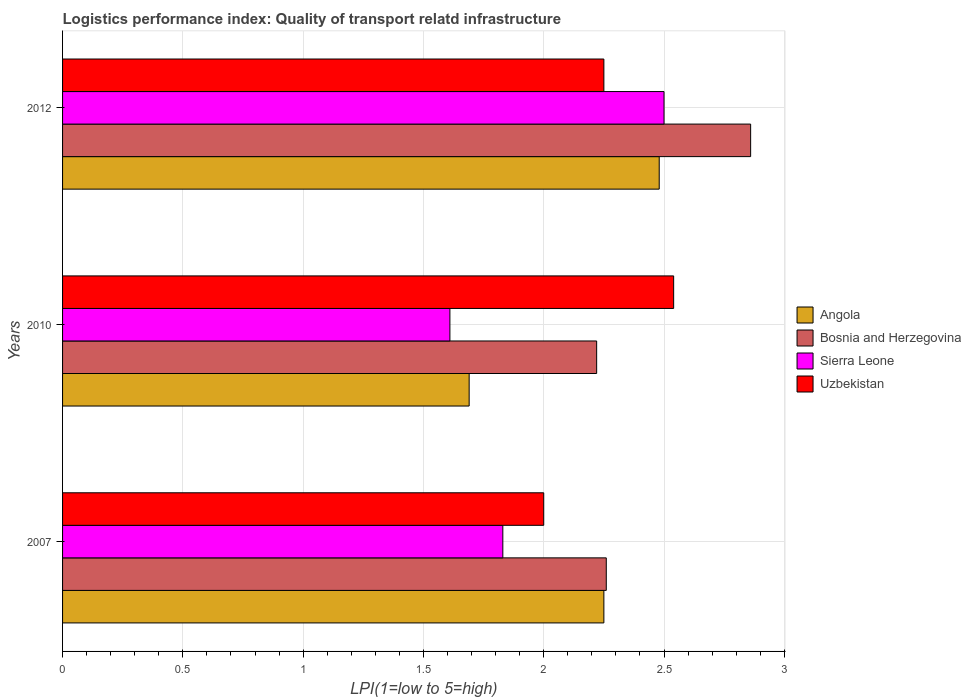How many different coloured bars are there?
Give a very brief answer. 4. How many groups of bars are there?
Provide a short and direct response. 3. Are the number of bars per tick equal to the number of legend labels?
Your response must be concise. Yes. Are the number of bars on each tick of the Y-axis equal?
Offer a terse response. Yes. How many bars are there on the 2nd tick from the top?
Your response must be concise. 4. What is the label of the 2nd group of bars from the top?
Ensure brevity in your answer.  2010. In how many cases, is the number of bars for a given year not equal to the number of legend labels?
Your answer should be compact. 0. What is the logistics performance index in Bosnia and Herzegovina in 2010?
Offer a very short reply. 2.22. Across all years, what is the maximum logistics performance index in Angola?
Keep it short and to the point. 2.48. Across all years, what is the minimum logistics performance index in Angola?
Offer a terse response. 1.69. In which year was the logistics performance index in Angola maximum?
Provide a short and direct response. 2012. What is the total logistics performance index in Bosnia and Herzegovina in the graph?
Provide a succinct answer. 7.34. What is the difference between the logistics performance index in Angola in 2007 and that in 2010?
Make the answer very short. 0.56. What is the difference between the logistics performance index in Uzbekistan in 2007 and the logistics performance index in Bosnia and Herzegovina in 2012?
Provide a succinct answer. -0.86. What is the average logistics performance index in Uzbekistan per year?
Ensure brevity in your answer.  2.26. In the year 2010, what is the difference between the logistics performance index in Sierra Leone and logistics performance index in Bosnia and Herzegovina?
Your response must be concise. -0.61. What is the ratio of the logistics performance index in Bosnia and Herzegovina in 2007 to that in 2010?
Give a very brief answer. 1.02. Is the difference between the logistics performance index in Sierra Leone in 2010 and 2012 greater than the difference between the logistics performance index in Bosnia and Herzegovina in 2010 and 2012?
Make the answer very short. No. What is the difference between the highest and the second highest logistics performance index in Sierra Leone?
Provide a short and direct response. 0.67. What is the difference between the highest and the lowest logistics performance index in Sierra Leone?
Keep it short and to the point. 0.89. Is it the case that in every year, the sum of the logistics performance index in Uzbekistan and logistics performance index in Sierra Leone is greater than the sum of logistics performance index in Bosnia and Herzegovina and logistics performance index in Angola?
Ensure brevity in your answer.  No. What does the 3rd bar from the top in 2007 represents?
Your response must be concise. Bosnia and Herzegovina. What does the 2nd bar from the bottom in 2012 represents?
Your answer should be compact. Bosnia and Herzegovina. How many bars are there?
Ensure brevity in your answer.  12. Are all the bars in the graph horizontal?
Make the answer very short. Yes. What is the difference between two consecutive major ticks on the X-axis?
Your answer should be compact. 0.5. Does the graph contain any zero values?
Your answer should be very brief. No. How many legend labels are there?
Your response must be concise. 4. What is the title of the graph?
Ensure brevity in your answer.  Logistics performance index: Quality of transport relatd infrastructure. Does "Europe(developing only)" appear as one of the legend labels in the graph?
Keep it short and to the point. No. What is the label or title of the X-axis?
Make the answer very short. LPI(1=low to 5=high). What is the label or title of the Y-axis?
Provide a short and direct response. Years. What is the LPI(1=low to 5=high) of Angola in 2007?
Provide a succinct answer. 2.25. What is the LPI(1=low to 5=high) of Bosnia and Herzegovina in 2007?
Make the answer very short. 2.26. What is the LPI(1=low to 5=high) of Sierra Leone in 2007?
Keep it short and to the point. 1.83. What is the LPI(1=low to 5=high) of Angola in 2010?
Your answer should be compact. 1.69. What is the LPI(1=low to 5=high) of Bosnia and Herzegovina in 2010?
Your answer should be very brief. 2.22. What is the LPI(1=low to 5=high) in Sierra Leone in 2010?
Offer a very short reply. 1.61. What is the LPI(1=low to 5=high) in Uzbekistan in 2010?
Offer a very short reply. 2.54. What is the LPI(1=low to 5=high) in Angola in 2012?
Your response must be concise. 2.48. What is the LPI(1=low to 5=high) in Bosnia and Herzegovina in 2012?
Make the answer very short. 2.86. What is the LPI(1=low to 5=high) of Sierra Leone in 2012?
Your answer should be very brief. 2.5. What is the LPI(1=low to 5=high) of Uzbekistan in 2012?
Offer a terse response. 2.25. Across all years, what is the maximum LPI(1=low to 5=high) in Angola?
Provide a succinct answer. 2.48. Across all years, what is the maximum LPI(1=low to 5=high) of Bosnia and Herzegovina?
Ensure brevity in your answer.  2.86. Across all years, what is the maximum LPI(1=low to 5=high) in Uzbekistan?
Offer a terse response. 2.54. Across all years, what is the minimum LPI(1=low to 5=high) of Angola?
Provide a short and direct response. 1.69. Across all years, what is the minimum LPI(1=low to 5=high) of Bosnia and Herzegovina?
Offer a terse response. 2.22. Across all years, what is the minimum LPI(1=low to 5=high) of Sierra Leone?
Provide a short and direct response. 1.61. Across all years, what is the minimum LPI(1=low to 5=high) in Uzbekistan?
Make the answer very short. 2. What is the total LPI(1=low to 5=high) of Angola in the graph?
Your response must be concise. 6.42. What is the total LPI(1=low to 5=high) of Bosnia and Herzegovina in the graph?
Make the answer very short. 7.34. What is the total LPI(1=low to 5=high) of Sierra Leone in the graph?
Your answer should be compact. 5.94. What is the total LPI(1=low to 5=high) of Uzbekistan in the graph?
Your answer should be very brief. 6.79. What is the difference between the LPI(1=low to 5=high) of Angola in 2007 and that in 2010?
Offer a very short reply. 0.56. What is the difference between the LPI(1=low to 5=high) of Bosnia and Herzegovina in 2007 and that in 2010?
Provide a succinct answer. 0.04. What is the difference between the LPI(1=low to 5=high) of Sierra Leone in 2007 and that in 2010?
Provide a succinct answer. 0.22. What is the difference between the LPI(1=low to 5=high) in Uzbekistan in 2007 and that in 2010?
Provide a short and direct response. -0.54. What is the difference between the LPI(1=low to 5=high) in Angola in 2007 and that in 2012?
Your answer should be compact. -0.23. What is the difference between the LPI(1=low to 5=high) in Bosnia and Herzegovina in 2007 and that in 2012?
Keep it short and to the point. -0.6. What is the difference between the LPI(1=low to 5=high) in Sierra Leone in 2007 and that in 2012?
Make the answer very short. -0.67. What is the difference between the LPI(1=low to 5=high) in Uzbekistan in 2007 and that in 2012?
Ensure brevity in your answer.  -0.25. What is the difference between the LPI(1=low to 5=high) in Angola in 2010 and that in 2012?
Give a very brief answer. -0.79. What is the difference between the LPI(1=low to 5=high) of Bosnia and Herzegovina in 2010 and that in 2012?
Make the answer very short. -0.64. What is the difference between the LPI(1=low to 5=high) of Sierra Leone in 2010 and that in 2012?
Your response must be concise. -0.89. What is the difference between the LPI(1=low to 5=high) in Uzbekistan in 2010 and that in 2012?
Your answer should be very brief. 0.29. What is the difference between the LPI(1=low to 5=high) of Angola in 2007 and the LPI(1=low to 5=high) of Sierra Leone in 2010?
Ensure brevity in your answer.  0.64. What is the difference between the LPI(1=low to 5=high) in Angola in 2007 and the LPI(1=low to 5=high) in Uzbekistan in 2010?
Give a very brief answer. -0.29. What is the difference between the LPI(1=low to 5=high) in Bosnia and Herzegovina in 2007 and the LPI(1=low to 5=high) in Sierra Leone in 2010?
Give a very brief answer. 0.65. What is the difference between the LPI(1=low to 5=high) in Bosnia and Herzegovina in 2007 and the LPI(1=low to 5=high) in Uzbekistan in 2010?
Your response must be concise. -0.28. What is the difference between the LPI(1=low to 5=high) of Sierra Leone in 2007 and the LPI(1=low to 5=high) of Uzbekistan in 2010?
Offer a very short reply. -0.71. What is the difference between the LPI(1=low to 5=high) in Angola in 2007 and the LPI(1=low to 5=high) in Bosnia and Herzegovina in 2012?
Keep it short and to the point. -0.61. What is the difference between the LPI(1=low to 5=high) in Angola in 2007 and the LPI(1=low to 5=high) in Uzbekistan in 2012?
Your answer should be very brief. 0. What is the difference between the LPI(1=low to 5=high) of Bosnia and Herzegovina in 2007 and the LPI(1=low to 5=high) of Sierra Leone in 2012?
Give a very brief answer. -0.24. What is the difference between the LPI(1=low to 5=high) in Bosnia and Herzegovina in 2007 and the LPI(1=low to 5=high) in Uzbekistan in 2012?
Offer a very short reply. 0.01. What is the difference between the LPI(1=low to 5=high) in Sierra Leone in 2007 and the LPI(1=low to 5=high) in Uzbekistan in 2012?
Keep it short and to the point. -0.42. What is the difference between the LPI(1=low to 5=high) of Angola in 2010 and the LPI(1=low to 5=high) of Bosnia and Herzegovina in 2012?
Provide a short and direct response. -1.17. What is the difference between the LPI(1=low to 5=high) of Angola in 2010 and the LPI(1=low to 5=high) of Sierra Leone in 2012?
Ensure brevity in your answer.  -0.81. What is the difference between the LPI(1=low to 5=high) of Angola in 2010 and the LPI(1=low to 5=high) of Uzbekistan in 2012?
Make the answer very short. -0.56. What is the difference between the LPI(1=low to 5=high) of Bosnia and Herzegovina in 2010 and the LPI(1=low to 5=high) of Sierra Leone in 2012?
Offer a very short reply. -0.28. What is the difference between the LPI(1=low to 5=high) in Bosnia and Herzegovina in 2010 and the LPI(1=low to 5=high) in Uzbekistan in 2012?
Give a very brief answer. -0.03. What is the difference between the LPI(1=low to 5=high) of Sierra Leone in 2010 and the LPI(1=low to 5=high) of Uzbekistan in 2012?
Make the answer very short. -0.64. What is the average LPI(1=low to 5=high) of Angola per year?
Your answer should be very brief. 2.14. What is the average LPI(1=low to 5=high) of Bosnia and Herzegovina per year?
Make the answer very short. 2.45. What is the average LPI(1=low to 5=high) in Sierra Leone per year?
Ensure brevity in your answer.  1.98. What is the average LPI(1=low to 5=high) of Uzbekistan per year?
Ensure brevity in your answer.  2.26. In the year 2007, what is the difference between the LPI(1=low to 5=high) of Angola and LPI(1=low to 5=high) of Bosnia and Herzegovina?
Your answer should be compact. -0.01. In the year 2007, what is the difference between the LPI(1=low to 5=high) in Angola and LPI(1=low to 5=high) in Sierra Leone?
Your answer should be compact. 0.42. In the year 2007, what is the difference between the LPI(1=low to 5=high) of Bosnia and Herzegovina and LPI(1=low to 5=high) of Sierra Leone?
Give a very brief answer. 0.43. In the year 2007, what is the difference between the LPI(1=low to 5=high) in Bosnia and Herzegovina and LPI(1=low to 5=high) in Uzbekistan?
Your answer should be compact. 0.26. In the year 2007, what is the difference between the LPI(1=low to 5=high) in Sierra Leone and LPI(1=low to 5=high) in Uzbekistan?
Keep it short and to the point. -0.17. In the year 2010, what is the difference between the LPI(1=low to 5=high) in Angola and LPI(1=low to 5=high) in Bosnia and Herzegovina?
Your response must be concise. -0.53. In the year 2010, what is the difference between the LPI(1=low to 5=high) in Angola and LPI(1=low to 5=high) in Sierra Leone?
Your answer should be compact. 0.08. In the year 2010, what is the difference between the LPI(1=low to 5=high) of Angola and LPI(1=low to 5=high) of Uzbekistan?
Your answer should be compact. -0.85. In the year 2010, what is the difference between the LPI(1=low to 5=high) in Bosnia and Herzegovina and LPI(1=low to 5=high) in Sierra Leone?
Ensure brevity in your answer.  0.61. In the year 2010, what is the difference between the LPI(1=low to 5=high) in Bosnia and Herzegovina and LPI(1=low to 5=high) in Uzbekistan?
Keep it short and to the point. -0.32. In the year 2010, what is the difference between the LPI(1=low to 5=high) of Sierra Leone and LPI(1=low to 5=high) of Uzbekistan?
Your answer should be very brief. -0.93. In the year 2012, what is the difference between the LPI(1=low to 5=high) in Angola and LPI(1=low to 5=high) in Bosnia and Herzegovina?
Provide a succinct answer. -0.38. In the year 2012, what is the difference between the LPI(1=low to 5=high) of Angola and LPI(1=low to 5=high) of Sierra Leone?
Your answer should be very brief. -0.02. In the year 2012, what is the difference between the LPI(1=low to 5=high) of Angola and LPI(1=low to 5=high) of Uzbekistan?
Keep it short and to the point. 0.23. In the year 2012, what is the difference between the LPI(1=low to 5=high) of Bosnia and Herzegovina and LPI(1=low to 5=high) of Sierra Leone?
Make the answer very short. 0.36. In the year 2012, what is the difference between the LPI(1=low to 5=high) of Bosnia and Herzegovina and LPI(1=low to 5=high) of Uzbekistan?
Provide a short and direct response. 0.61. What is the ratio of the LPI(1=low to 5=high) in Angola in 2007 to that in 2010?
Make the answer very short. 1.33. What is the ratio of the LPI(1=low to 5=high) in Bosnia and Herzegovina in 2007 to that in 2010?
Provide a short and direct response. 1.02. What is the ratio of the LPI(1=low to 5=high) of Sierra Leone in 2007 to that in 2010?
Provide a succinct answer. 1.14. What is the ratio of the LPI(1=low to 5=high) in Uzbekistan in 2007 to that in 2010?
Provide a succinct answer. 0.79. What is the ratio of the LPI(1=low to 5=high) in Angola in 2007 to that in 2012?
Offer a very short reply. 0.91. What is the ratio of the LPI(1=low to 5=high) in Bosnia and Herzegovina in 2007 to that in 2012?
Ensure brevity in your answer.  0.79. What is the ratio of the LPI(1=low to 5=high) of Sierra Leone in 2007 to that in 2012?
Offer a very short reply. 0.73. What is the ratio of the LPI(1=low to 5=high) in Angola in 2010 to that in 2012?
Your answer should be very brief. 0.68. What is the ratio of the LPI(1=low to 5=high) of Bosnia and Herzegovina in 2010 to that in 2012?
Your answer should be very brief. 0.78. What is the ratio of the LPI(1=low to 5=high) in Sierra Leone in 2010 to that in 2012?
Ensure brevity in your answer.  0.64. What is the ratio of the LPI(1=low to 5=high) of Uzbekistan in 2010 to that in 2012?
Your response must be concise. 1.13. What is the difference between the highest and the second highest LPI(1=low to 5=high) in Angola?
Ensure brevity in your answer.  0.23. What is the difference between the highest and the second highest LPI(1=low to 5=high) of Bosnia and Herzegovina?
Make the answer very short. 0.6. What is the difference between the highest and the second highest LPI(1=low to 5=high) of Sierra Leone?
Provide a short and direct response. 0.67. What is the difference between the highest and the second highest LPI(1=low to 5=high) of Uzbekistan?
Provide a succinct answer. 0.29. What is the difference between the highest and the lowest LPI(1=low to 5=high) in Angola?
Provide a succinct answer. 0.79. What is the difference between the highest and the lowest LPI(1=low to 5=high) in Bosnia and Herzegovina?
Offer a very short reply. 0.64. What is the difference between the highest and the lowest LPI(1=low to 5=high) of Sierra Leone?
Your response must be concise. 0.89. What is the difference between the highest and the lowest LPI(1=low to 5=high) of Uzbekistan?
Your response must be concise. 0.54. 